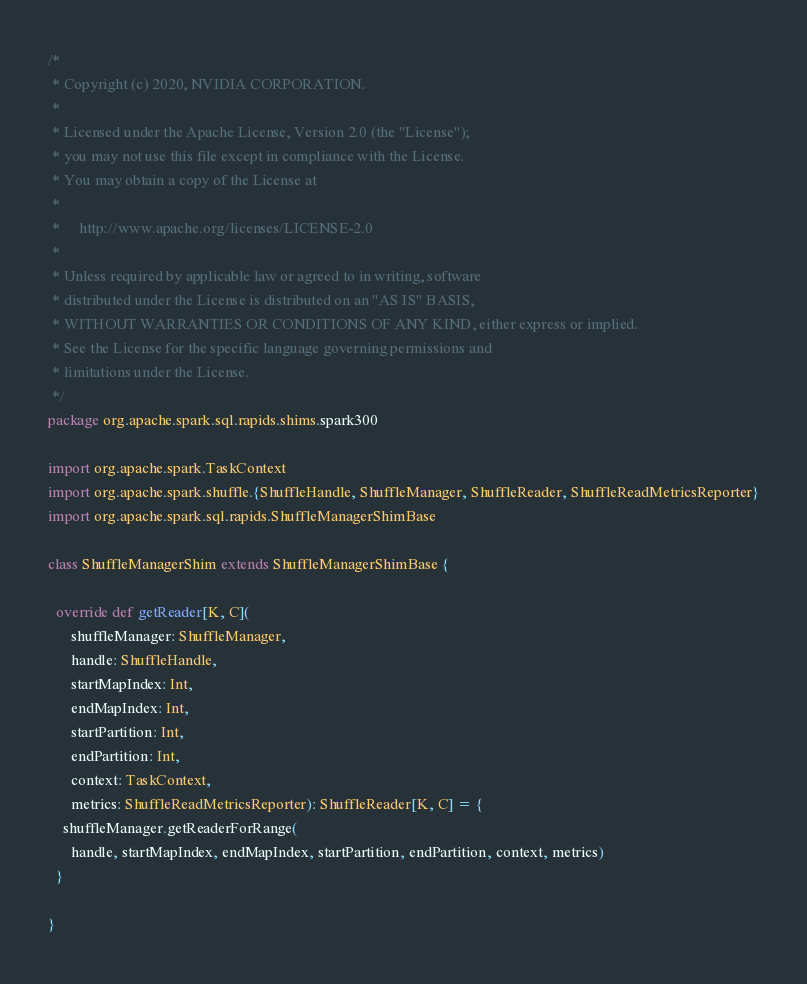<code> <loc_0><loc_0><loc_500><loc_500><_Scala_>/*
 * Copyright (c) 2020, NVIDIA CORPORATION.
 *
 * Licensed under the Apache License, Version 2.0 (the "License");
 * you may not use this file except in compliance with the License.
 * You may obtain a copy of the License at
 *
 *     http://www.apache.org/licenses/LICENSE-2.0
 *
 * Unless required by applicable law or agreed to in writing, software
 * distributed under the License is distributed on an "AS IS" BASIS,
 * WITHOUT WARRANTIES OR CONDITIONS OF ANY KIND, either express or implied.
 * See the License for the specific language governing permissions and
 * limitations under the License.
 */
package org.apache.spark.sql.rapids.shims.spark300

import org.apache.spark.TaskContext
import org.apache.spark.shuffle.{ShuffleHandle, ShuffleManager, ShuffleReader, ShuffleReadMetricsReporter}
import org.apache.spark.sql.rapids.ShuffleManagerShimBase

class ShuffleManagerShim extends ShuffleManagerShimBase {

  override def getReader[K, C](
      shuffleManager: ShuffleManager,
      handle: ShuffleHandle,
      startMapIndex: Int,
      endMapIndex: Int,
      startPartition: Int,
      endPartition: Int,
      context: TaskContext,
      metrics: ShuffleReadMetricsReporter): ShuffleReader[K, C] = {
    shuffleManager.getReaderForRange(
      handle, startMapIndex, endMapIndex, startPartition, endPartition, context, metrics)
  }

}
</code> 